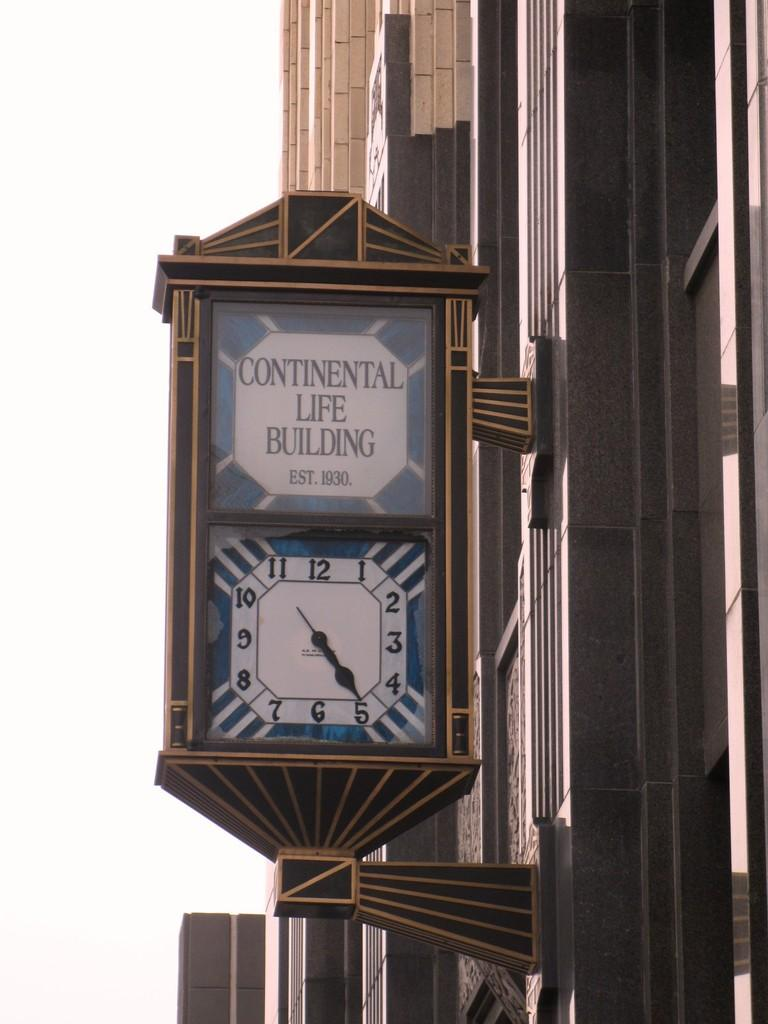<image>
Render a clear and concise summary of the photo. The clock is on the side of the Continental Life Building 